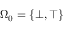Convert formula to latex. <formula><loc_0><loc_0><loc_500><loc_500>\Omega _ { 0 } = \{ \bot , \top \}</formula> 